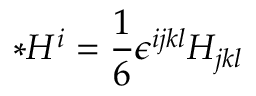Convert formula to latex. <formula><loc_0><loc_0><loc_500><loc_500>{ \ast } H ^ { i } = \frac { 1 } { 6 } \epsilon ^ { i j k l } H _ { j k l }</formula> 